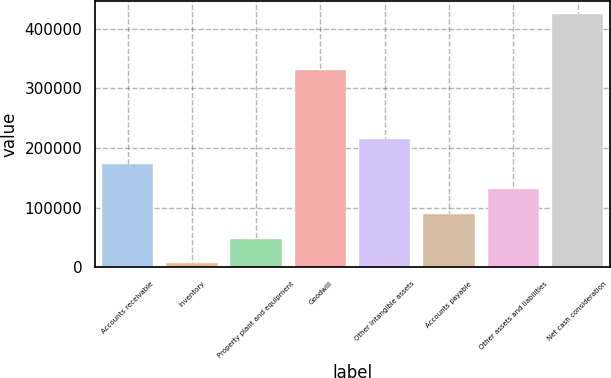<chart> <loc_0><loc_0><loc_500><loc_500><bar_chart><fcel>Accounts receivable<fcel>Inventory<fcel>Property plant and equipment<fcel>Goodwill<fcel>Other intangible assets<fcel>Accounts payable<fcel>Other assets and liabilities<fcel>Net cash consideration<nl><fcel>173791<fcel>6541<fcel>48353.5<fcel>330847<fcel>215604<fcel>90166<fcel>131978<fcel>424666<nl></chart> 